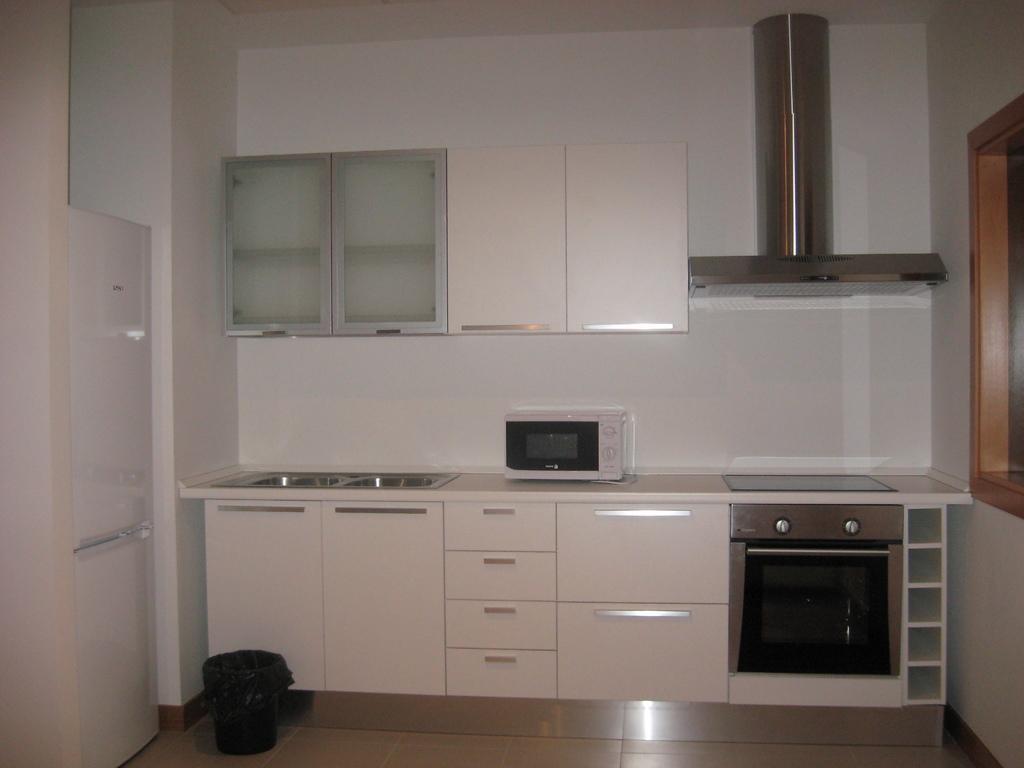How would you summarize this image in a sentence or two? In this picture I can observe a room. In the middle of the picture I can observe an oven placed on the desk. I can observe white color cupboards in this picture. On the right side there is a chimney. In the background I can observe wall. 